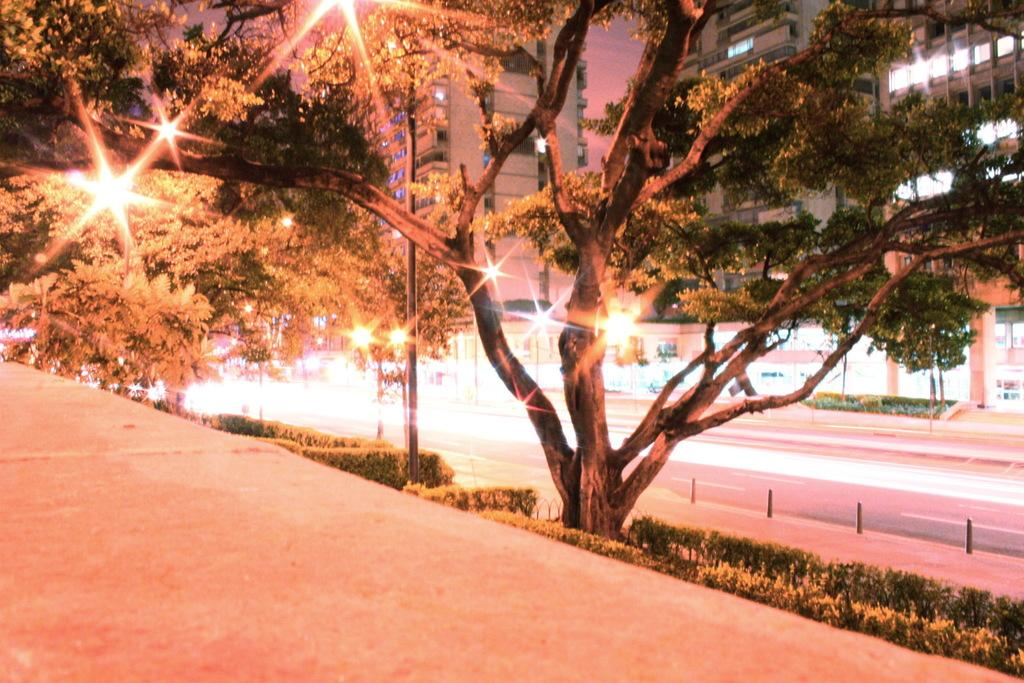What type of vegetation can be seen beside the road in the image? There are plants and trees beside the road in the image. What can be seen in the background of the image? There are lights and buildings in the background of the image. What type of rhythm can be heard coming from the hydrant in the image? There is no hydrant present in the image, and therefore no rhythm can be heard. 